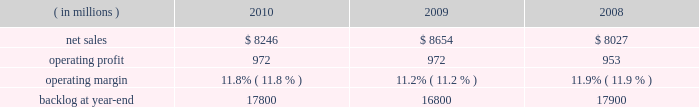Operating profit for the segment decreased by 1% ( 1 % ) in 2010 compared to 2009 .
For the year , operating profit declines in defense more than offset an increase in civil , while operating profit at intelligence essentially was unchanged .
The $ 27 million decrease in operating profit at defense primarily was attributable to a decrease in the level of favorable performance adjustments on mission and combat systems activities in 2010 .
The $ 19 million increase in civil principally was due to higher volume on enterprise civilian services .
Operating profit for the segment decreased by 3% ( 3 % ) in 2009 compared to 2008 .
Operating profit declines in civil and intelligence partially were offset by growth in defense .
The decrease of $ 29 million in civil 2019s operating profit primarily was attributable to a reduction in the level of favorable performance adjustments on enterprise civilian services programs in 2009 compared to 2008 .
The decrease in operating profit of $ 27 million at intelligence mainly was due to a reduction in the level of favorable performance adjustments on security solution activities in 2009 compared to 2008 .
The increase in defense 2019s operating profit of $ 29 million mainly was due to volume and improved performance in mission and combat systems .
The decrease in backlog during 2010 compared to 2009 mainly was due to higher sales volume on enterprise civilian service programs at civil , including volume associated with the dris 2010 program , and mission and combat system programs at defense .
Backlog decreased in 2009 compared to 2008 due to u.s .
Government 2019s exercise of the termination for convenience clause on the tsat mission operations system ( tmos ) contract at defense , which resulted in a $ 1.6 billion reduction in orders .
This decline more than offset increased orders on enterprise civilian services programs at civil .
We expect is&gs will experience a low single digit percentage decrease in sales for 2011 as compared to 2010 .
This decline primarily is due to completion of most of the work associated with the dris 2010 program .
Operating profit in 2011 is expected to decline in relationship to the decline in sales volume , while operating margins are expected to be comparable between the years .
Space systems our space systems business segment is engaged in the design , research and development , engineering , and production of satellites , strategic and defensive missile systems , and space transportation systems , including activities related to the planned replacement of the space shuttle .
Government satellite programs include the advanced extremely high frequency ( aehf ) system , the mobile user objective system ( muos ) , the global positioning satellite iii ( gps iii ) system , the space-based infrared system ( sbirs ) , and the geostationary operational environmental satellite r-series ( goes-r ) .
Strategic and missile defense programs include the targets and countermeasures program and the fleet ballistic missile program .
Space transportation includes the nasa orion program and , through ownership interests in two joint ventures , expendable launch services ( united launch alliance , or ula ) and space shuttle processing activities for the u.s .
Government ( united space alliance , or usa ) .
The space shuttle is expected to complete its final flight mission in 2011 and our involvement with its launch and processing activities will end at that time .
Space systems 2019 operating results included the following : ( in millions ) 2010 2009 2008 .
Net sales for space systems decreased by 5% ( 5 % ) in 2010 compared to 2009 .
Sales declined in all three lines of business during the year .
The $ 253 million decrease in space transportation principally was due to lower volume on the space shuttle external tank , commercial launch vehicle activity and other human space flight programs , which partially were offset by higher volume on the orion program .
There were no commercial launches in 2010 compared to one commercial launch in 2009 .
Strategic & defensive missile systems ( s&dms ) sales declined $ 147 million principally due to lower volume on defensive missile programs .
The $ 8 million sales decline in satellites primarily was attributable to lower volume on commercial satellites , which partially were offset by higher volume on government satellite activities .
There was one commercial satellite delivery in 2010 and one commercial satellite delivery in 2009 .
Net sales for space systems increased 8% ( 8 % ) in 2009 compared to 2008 .
During the year , sales growth at satellites and space transportation offset a decline in s&dms .
The sales growth of $ 707 million in satellites was due to higher volume in government satellite activities , which partially was offset by lower volume in commercial satellite activities .
There was one commercial satellite delivery in 2009 and two deliveries in 2008 .
The increase in sales of $ 21 million in space transportation primarily was due to higher volume on the orion program , which more than offset a decline in the space shuttle 2019s external tank program .
There was one commercial launch in both 2009 and 2008 .
S&dms 2019 sales decreased by $ 102 million mainly due to lower volume on defensive missile programs , which more than offset growth in strategic missile programs. .
What is the growth rate of operating expenses from 2009 to 2010? 
Computations: (((8246 - 972) - (8654 - 972)) / (8654 - 972))
Answer: -0.05311. 